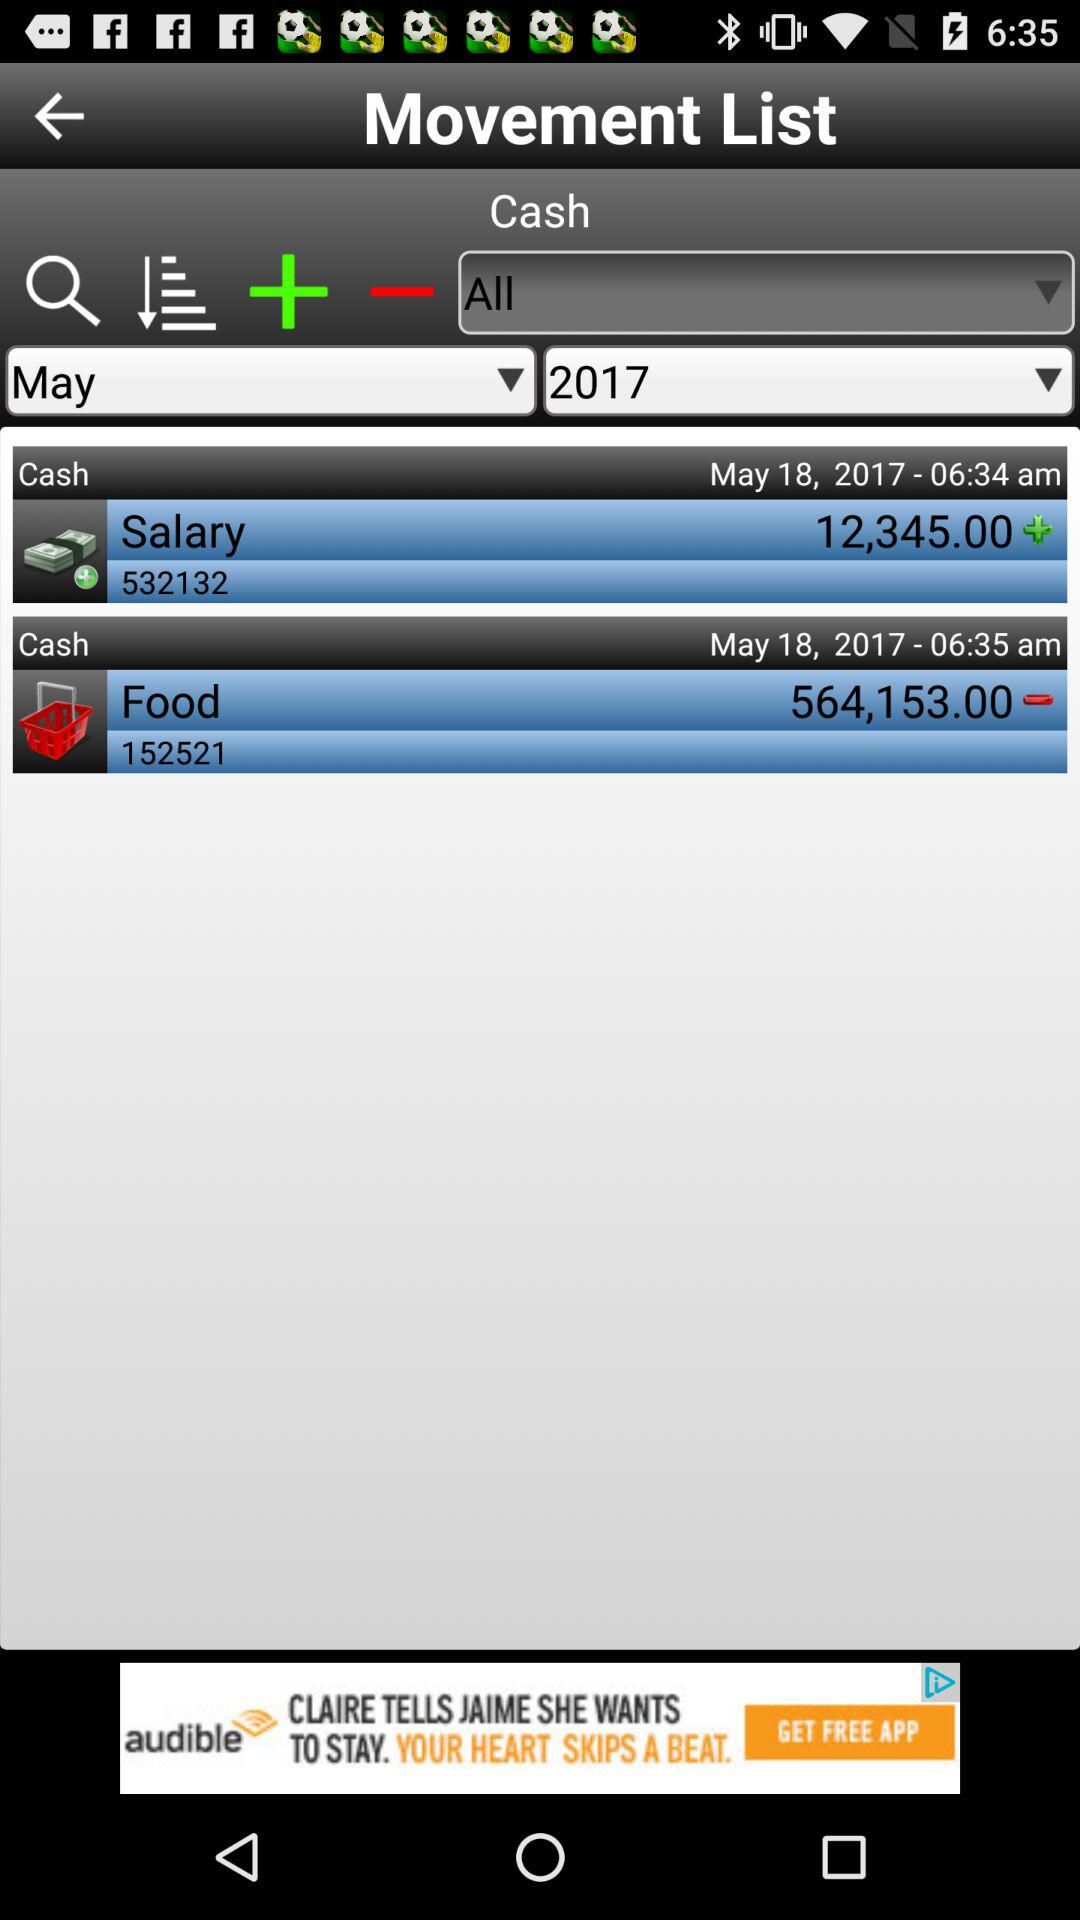What is the month and year of the movement list? The month and year of the movement list are May and 2017, respectively. 